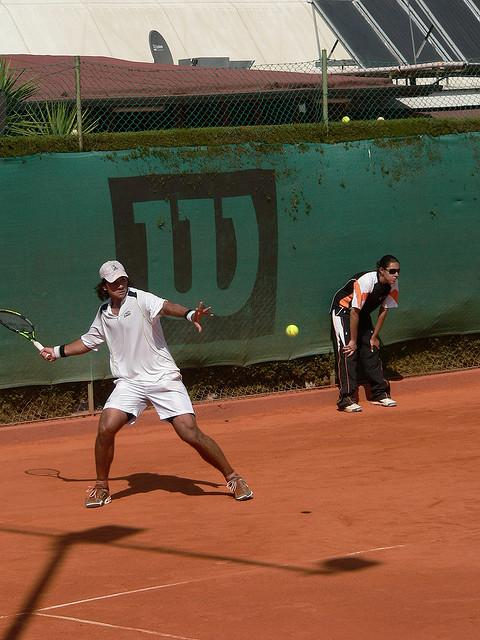What powers the facilities in this area? solar panels 